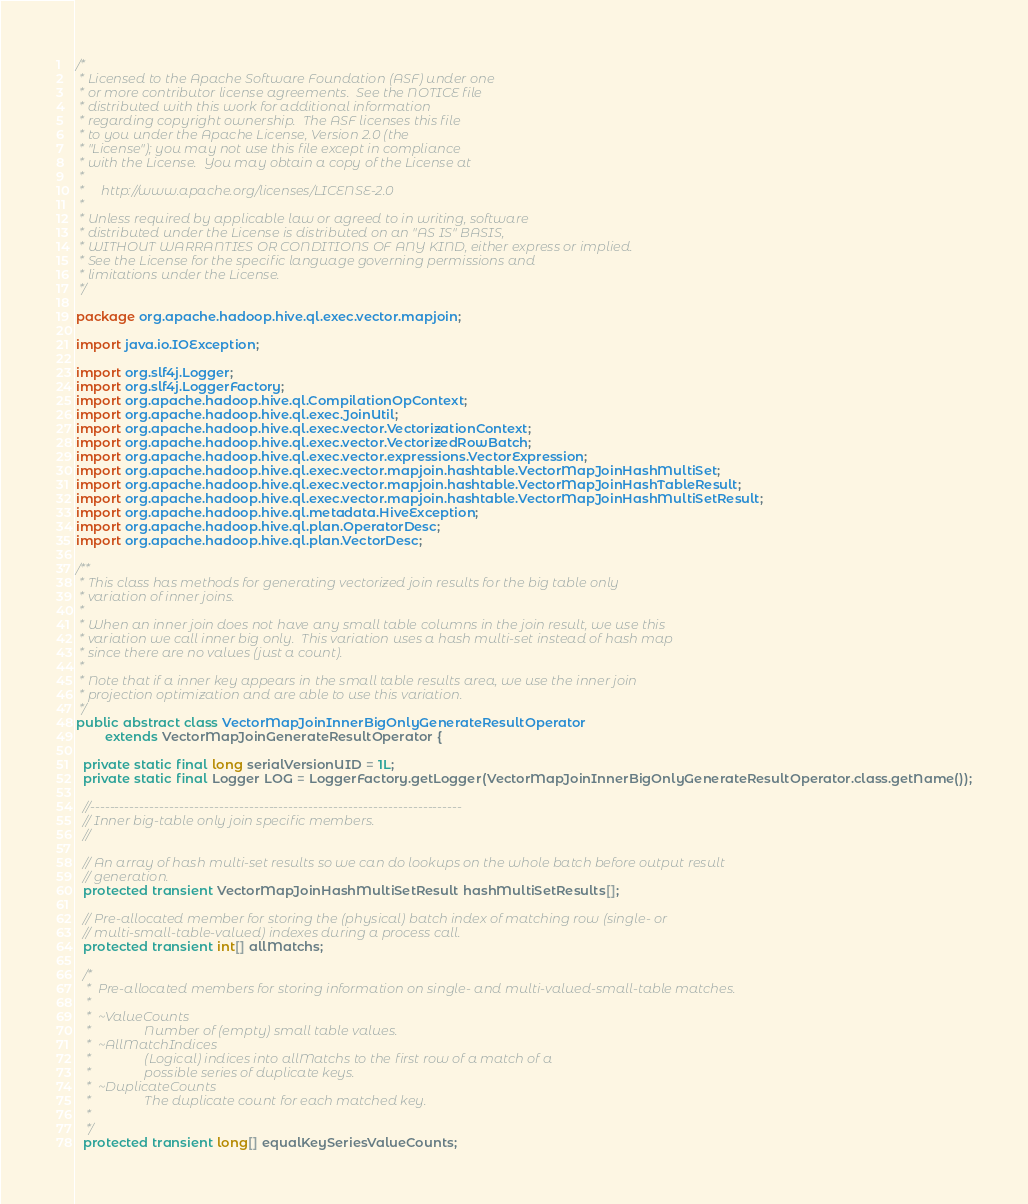<code> <loc_0><loc_0><loc_500><loc_500><_Java_>/*
 * Licensed to the Apache Software Foundation (ASF) under one
 * or more contributor license agreements.  See the NOTICE file
 * distributed with this work for additional information
 * regarding copyright ownership.  The ASF licenses this file
 * to you under the Apache License, Version 2.0 (the
 * "License"); you may not use this file except in compliance
 * with the License.  You may obtain a copy of the License at
 *
 *     http://www.apache.org/licenses/LICENSE-2.0
 *
 * Unless required by applicable law or agreed to in writing, software
 * distributed under the License is distributed on an "AS IS" BASIS,
 * WITHOUT WARRANTIES OR CONDITIONS OF ANY KIND, either express or implied.
 * See the License for the specific language governing permissions and
 * limitations under the License.
 */

package org.apache.hadoop.hive.ql.exec.vector.mapjoin;

import java.io.IOException;

import org.slf4j.Logger;
import org.slf4j.LoggerFactory;
import org.apache.hadoop.hive.ql.CompilationOpContext;
import org.apache.hadoop.hive.ql.exec.JoinUtil;
import org.apache.hadoop.hive.ql.exec.vector.VectorizationContext;
import org.apache.hadoop.hive.ql.exec.vector.VectorizedRowBatch;
import org.apache.hadoop.hive.ql.exec.vector.expressions.VectorExpression;
import org.apache.hadoop.hive.ql.exec.vector.mapjoin.hashtable.VectorMapJoinHashMultiSet;
import org.apache.hadoop.hive.ql.exec.vector.mapjoin.hashtable.VectorMapJoinHashTableResult;
import org.apache.hadoop.hive.ql.exec.vector.mapjoin.hashtable.VectorMapJoinHashMultiSetResult;
import org.apache.hadoop.hive.ql.metadata.HiveException;
import org.apache.hadoop.hive.ql.plan.OperatorDesc;
import org.apache.hadoop.hive.ql.plan.VectorDesc;

/**
 * This class has methods for generating vectorized join results for the big table only
 * variation of inner joins.
 *
 * When an inner join does not have any small table columns in the join result, we use this
 * variation we call inner big only.  This variation uses a hash multi-set instead of hash map
 * since there are no values (just a count).
 *
 * Note that if a inner key appears in the small table results area, we use the inner join
 * projection optimization and are able to use this variation.
 */
public abstract class VectorMapJoinInnerBigOnlyGenerateResultOperator
        extends VectorMapJoinGenerateResultOperator {

  private static final long serialVersionUID = 1L;
  private static final Logger LOG = LoggerFactory.getLogger(VectorMapJoinInnerBigOnlyGenerateResultOperator.class.getName());

  //---------------------------------------------------------------------------
  // Inner big-table only join specific members.
  //

  // An array of hash multi-set results so we can do lookups on the whole batch before output result
  // generation.
  protected transient VectorMapJoinHashMultiSetResult hashMultiSetResults[];

  // Pre-allocated member for storing the (physical) batch index of matching row (single- or
  // multi-small-table-valued) indexes during a process call.
  protected transient int[] allMatchs;

  /*
   *  Pre-allocated members for storing information on single- and multi-valued-small-table matches.
   *
   *  ~ValueCounts
   *                Number of (empty) small table values.
   *  ~AllMatchIndices
   *                (Logical) indices into allMatchs to the first row of a match of a
   *                possible series of duplicate keys.
   *  ~DuplicateCounts
   *                The duplicate count for each matched key.
   *
   */
  protected transient long[] equalKeySeriesValueCounts;</code> 